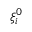<formula> <loc_0><loc_0><loc_500><loc_500>\xi _ { i } ^ { 0 }</formula> 